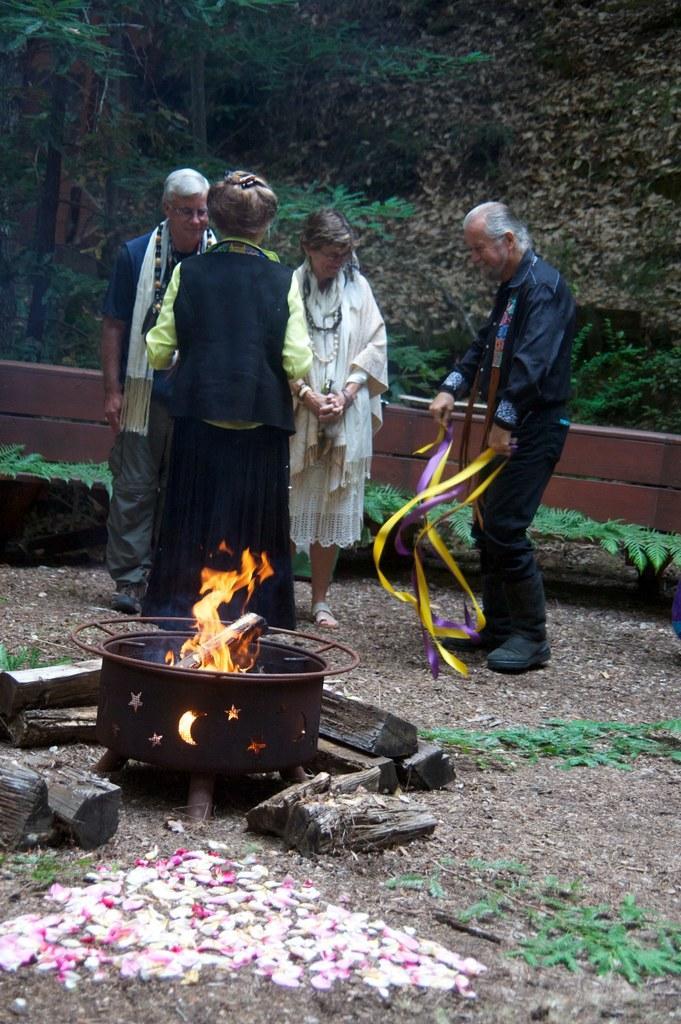Could you give a brief overview of what you see in this image? In the image we can see there are four people standing wearing clothes. Here we can see the flame, wooden sticks, metal container, grass, wooden fence and trees. 